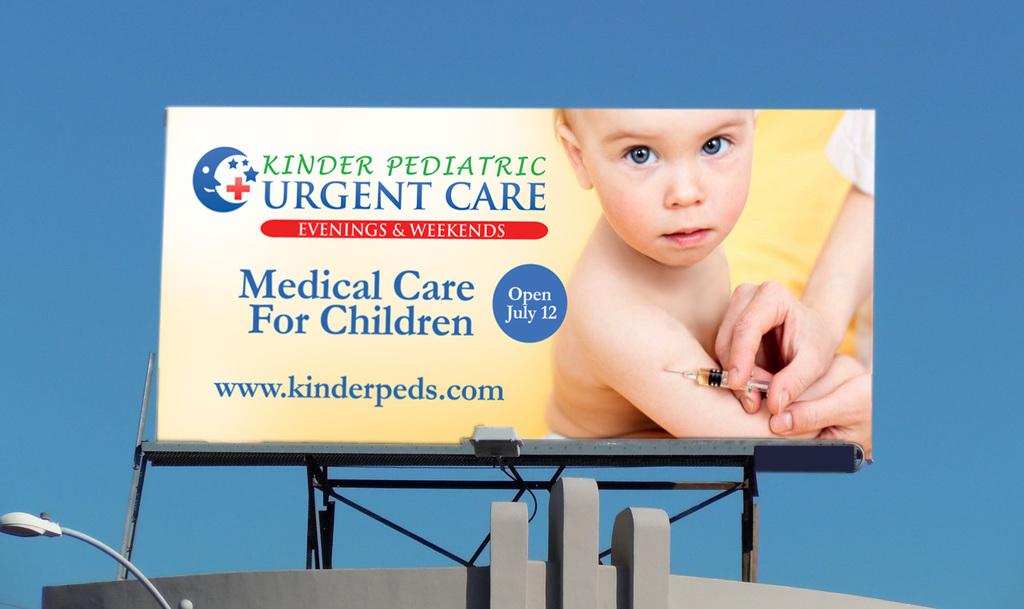What day does urgent care open?
Your answer should be very brief. July 12. What kind of medical care is offered?
Your answer should be very brief. For children. 